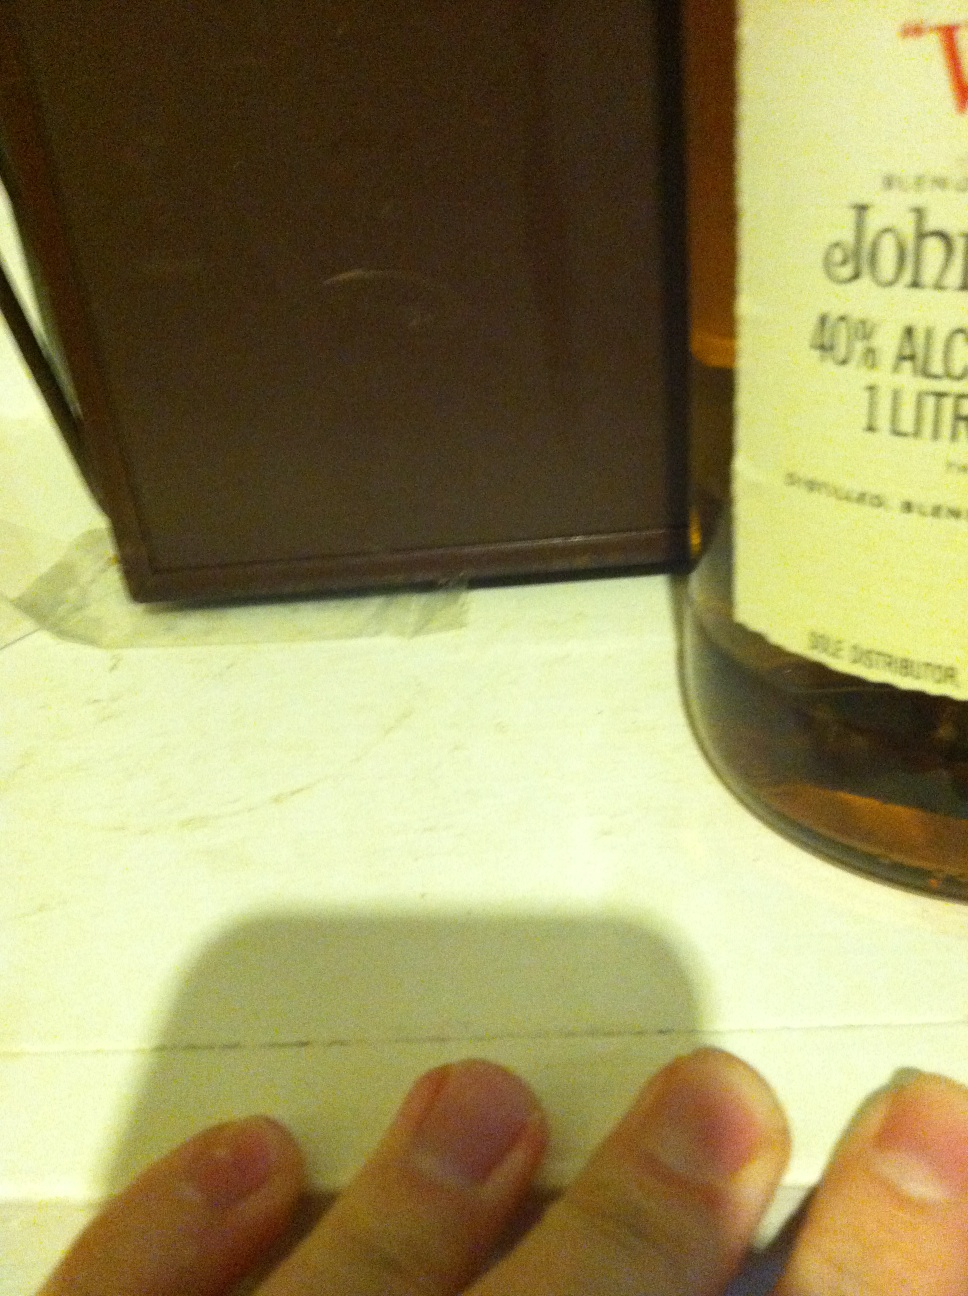Can you write a poem inspired by this whisky bottle? In amber glow, the stories told,
A liquid gold, so rich, so bold.
Through years and oak, its essence grew,
A timeless craft in droplets few.
In every sip, a journey's spark,
A blending art, both light and dark.
Beneath the label, tales confined,
A whisky's soul for hearts to find. 